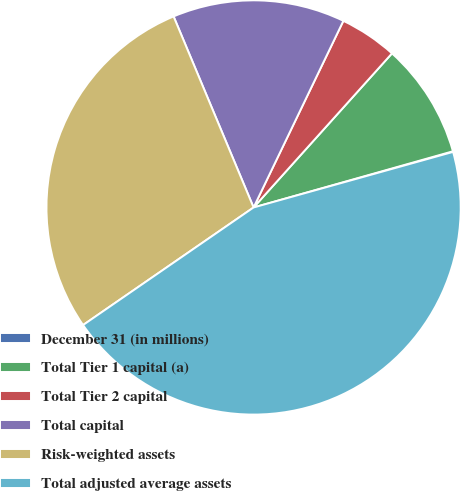Convert chart to OTSL. <chart><loc_0><loc_0><loc_500><loc_500><pie_chart><fcel>December 31 (in millions)<fcel>Total Tier 1 capital (a)<fcel>Total Tier 2 capital<fcel>Total capital<fcel>Risk-weighted assets<fcel>Total adjusted average assets<nl><fcel>0.05%<fcel>8.98%<fcel>4.51%<fcel>13.45%<fcel>28.3%<fcel>44.72%<nl></chart> 